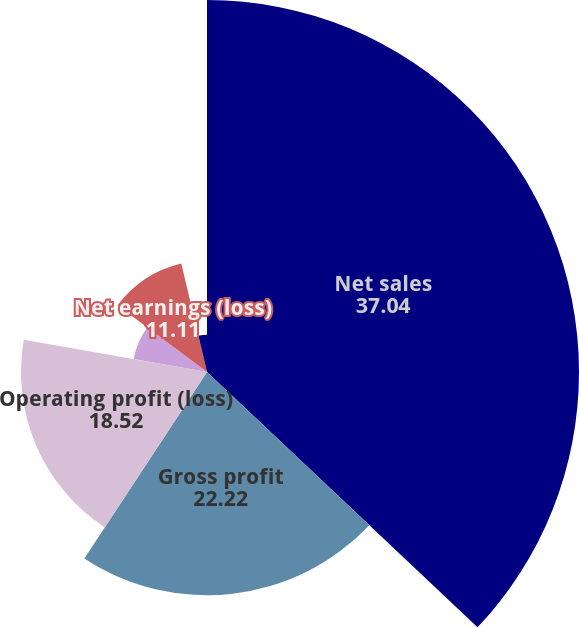Convert chart. <chart><loc_0><loc_0><loc_500><loc_500><pie_chart><fcel>Net sales<fcel>Gross profit<fcel>Operating profit (loss)<fcel>Earnings (loss) from<fcel>Net earnings (loss)<fcel>Earnings (loss) per share -<nl><fcel>37.04%<fcel>22.22%<fcel>18.52%<fcel>7.41%<fcel>11.11%<fcel>3.7%<nl></chart> 